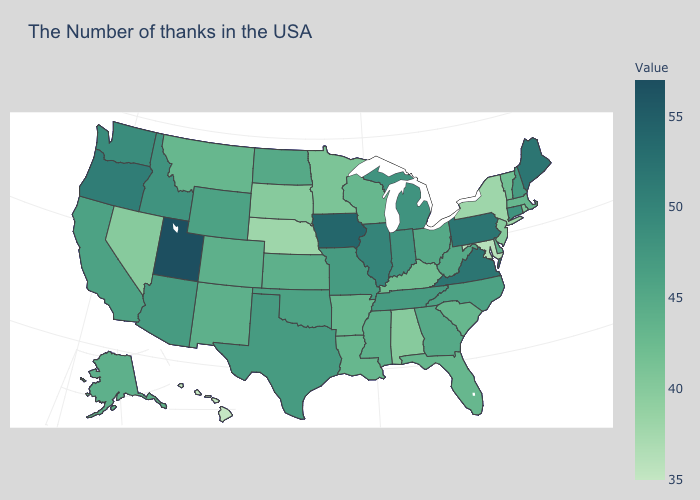Which states have the lowest value in the Northeast?
Be succinct. New York. Does the map have missing data?
Keep it brief. No. Does the map have missing data?
Give a very brief answer. No. Does California have a lower value than Arkansas?
Answer briefly. No. Which states have the highest value in the USA?
Keep it brief. Utah. Does New York have the lowest value in the Northeast?
Write a very short answer. Yes. Among the states that border Mississippi , does Arkansas have the highest value?
Answer briefly. No. Which states have the lowest value in the USA?
Quick response, please. Hawaii. Which states have the highest value in the USA?
Quick response, please. Utah. 